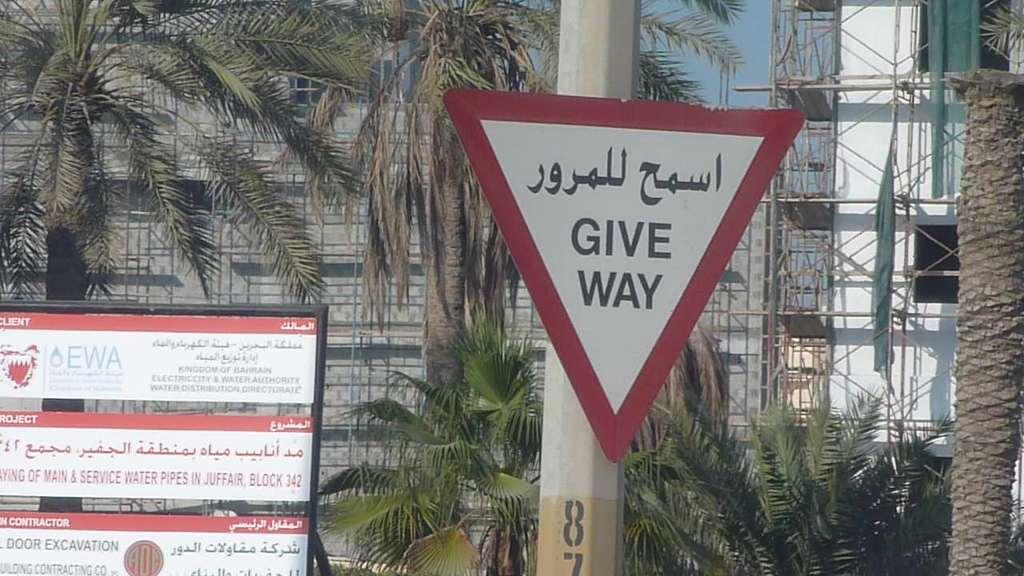What can be seen on the boards in the image? There are boards with text in the image. What is attached to the pole in the image? There is a pole with a board in the image. What type of vegetation is present in the image? There are trees in the image. What type of structures can be seen in the image? There are buildings in the image. What type of material is used for the rods in the image? There are metal rods in the image. What is visible in the background of the image? The sky is visible in the background of the image. What type of trousers are the sisters wearing in the image? There are no people, let alone sisters, present in the image. How many wings can be seen on the buildings in the image? There are no wings visible on the buildings in the image. 